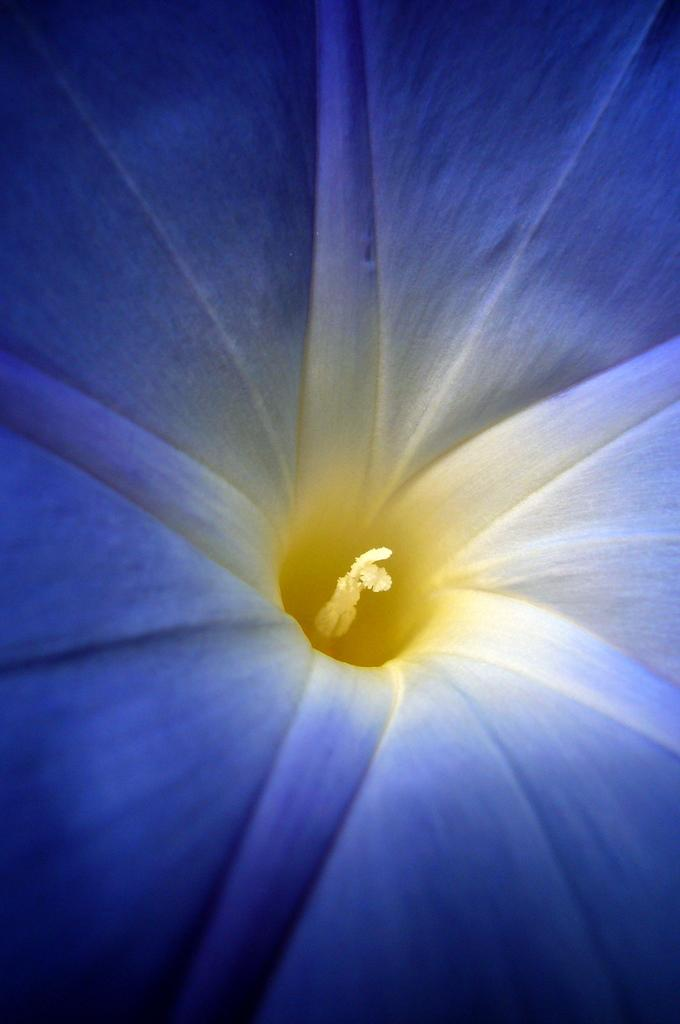What color is the flower in the image? The flower in the image is blue. What part of the flower is yellow? The stigma of the flower is yellow. What is the weight of the carriage in the image? There is no carriage present in the image, so it is not possible to determine its weight. 